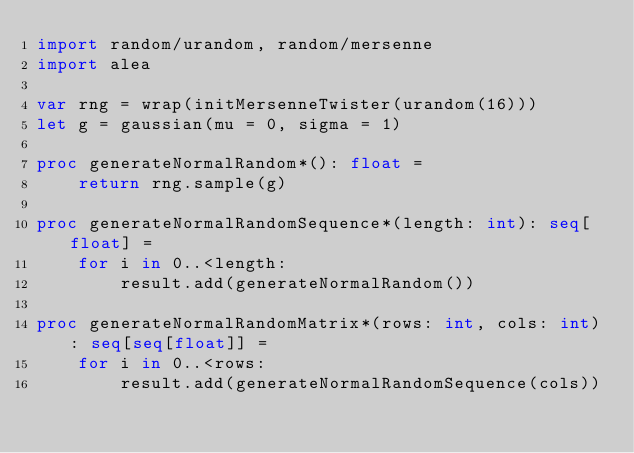<code> <loc_0><loc_0><loc_500><loc_500><_Nim_>import random/urandom, random/mersenne
import alea

var rng = wrap(initMersenneTwister(urandom(16)))
let g = gaussian(mu = 0, sigma = 1)

proc generateNormalRandom*(): float =
    return rng.sample(g)

proc generateNormalRandomSequence*(length: int): seq[float] =
    for i in 0..<length:
        result.add(generateNormalRandom())

proc generateNormalRandomMatrix*(rows: int, cols: int): seq[seq[float]] =
    for i in 0..<rows:
        result.add(generateNormalRandomSequence(cols))
</code> 